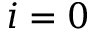<formula> <loc_0><loc_0><loc_500><loc_500>i = 0</formula> 